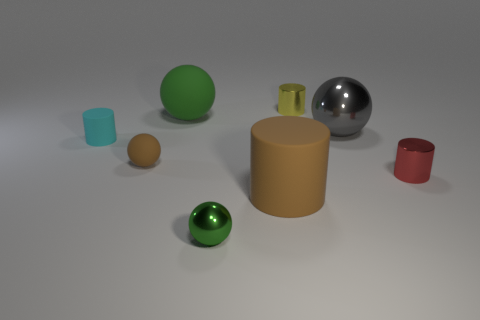Is there a small cyan object?
Your answer should be very brief. Yes. Are there more shiny spheres behind the tiny green shiny ball than tiny green objects that are to the right of the large brown thing?
Make the answer very short. Yes. There is a small object left of the brown thing behind the small red cylinder; what is its color?
Make the answer very short. Cyan. Are there any tiny metallic things of the same color as the big metallic ball?
Offer a very short reply. No. What size is the brown matte thing on the left side of the metallic ball in front of the tiny cyan thing left of the big matte ball?
Your answer should be compact. Small. The yellow metal thing is what shape?
Your answer should be compact. Cylinder. There is a object that is the same color as the big matte sphere; what is its size?
Offer a very short reply. Small. There is a small green object that is on the right side of the tiny brown object; what number of yellow things are in front of it?
Your answer should be compact. 0. Is the small cylinder on the left side of the tiny brown thing made of the same material as the ball that is in front of the red thing?
Your answer should be very brief. No. Is there anything else that has the same shape as the tiny cyan thing?
Ensure brevity in your answer.  Yes. 